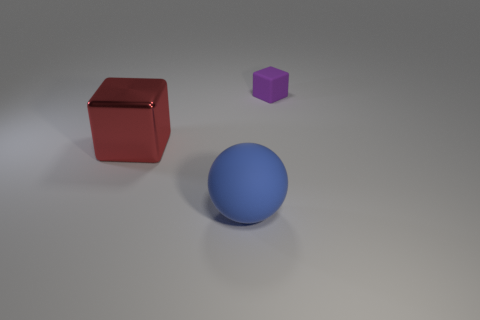What size is the cube to the left of the object to the right of the ball?
Your answer should be very brief. Large. What material is the thing that is left of the tiny purple cube and right of the large red metal thing?
Your answer should be very brief. Rubber. The large metallic object has what color?
Offer a terse response. Red. Is there anything else that has the same material as the red cube?
Offer a very short reply. No. What shape is the rubber object that is to the left of the purple rubber block?
Ensure brevity in your answer.  Sphere. There is a large object to the right of the cube that is in front of the purple object; is there a shiny thing that is in front of it?
Your response must be concise. No. Is there anything else that has the same shape as the purple matte thing?
Give a very brief answer. Yes. Is there a brown thing?
Offer a terse response. No. Do the block in front of the small purple rubber block and the cube right of the blue matte sphere have the same material?
Make the answer very short. No. There is a purple matte cube right of the blue rubber object right of the cube in front of the purple block; what size is it?
Give a very brief answer. Small. 